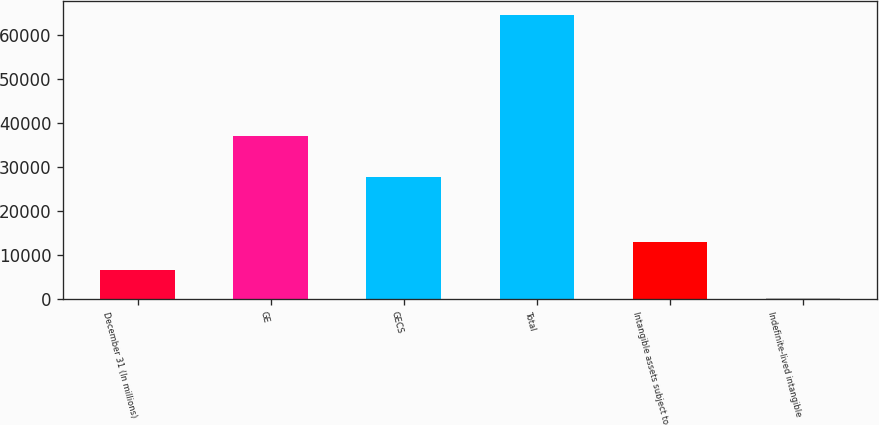Convert chart. <chart><loc_0><loc_0><loc_500><loc_500><bar_chart><fcel>December 31 (In millions)<fcel>GE<fcel>GECS<fcel>Total<fcel>Intangible assets subject to<fcel>Indefinite-lived intangible<nl><fcel>6540.9<fcel>36880<fcel>27593<fcel>64473<fcel>12977.8<fcel>104<nl></chart> 